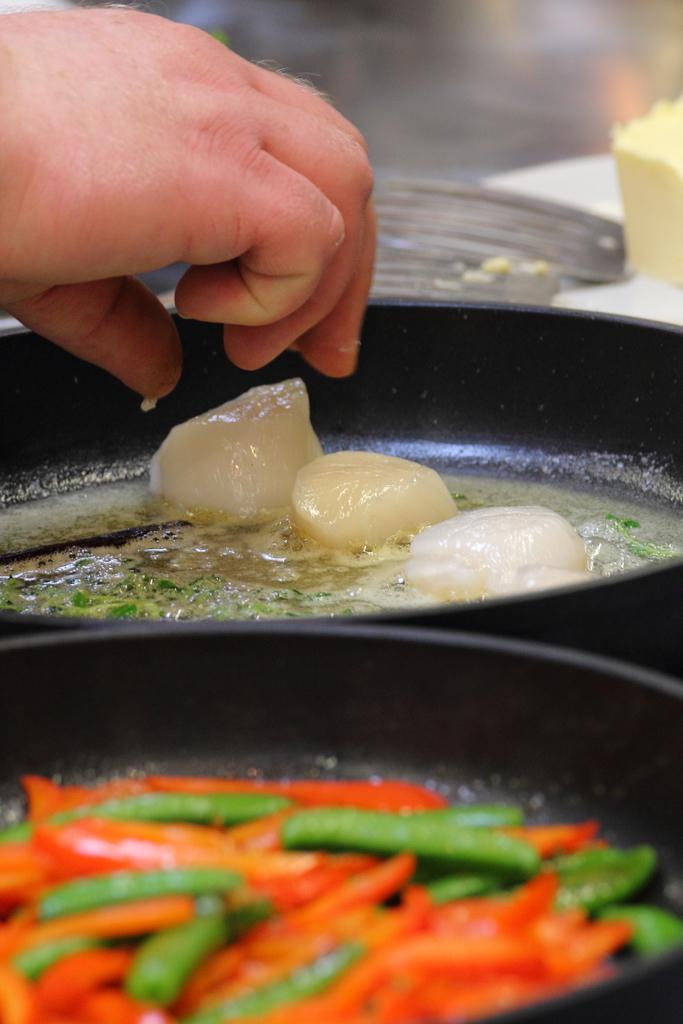Can you describe this image briefly? In this image in front there are food items in the pan and we can see a hand of a person. There is butter on the table. 